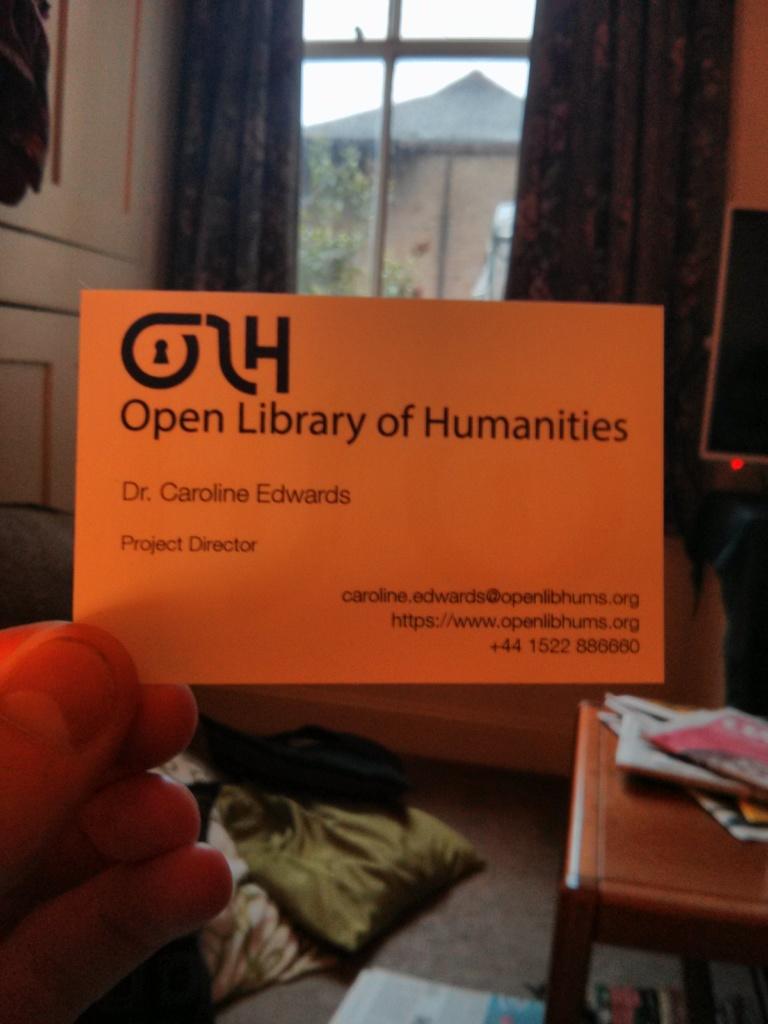Who is the dr's name on the card?
Make the answer very short. Caroline edwards. Is this the card of a project director?
Your response must be concise. Yes. 